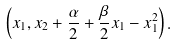<formula> <loc_0><loc_0><loc_500><loc_500>\left ( x _ { 1 } , x _ { 2 } + \frac { \alpha } { 2 } + \frac { \beta } { 2 } x _ { 1 } - x _ { 1 } ^ { 2 } \right ) .</formula> 